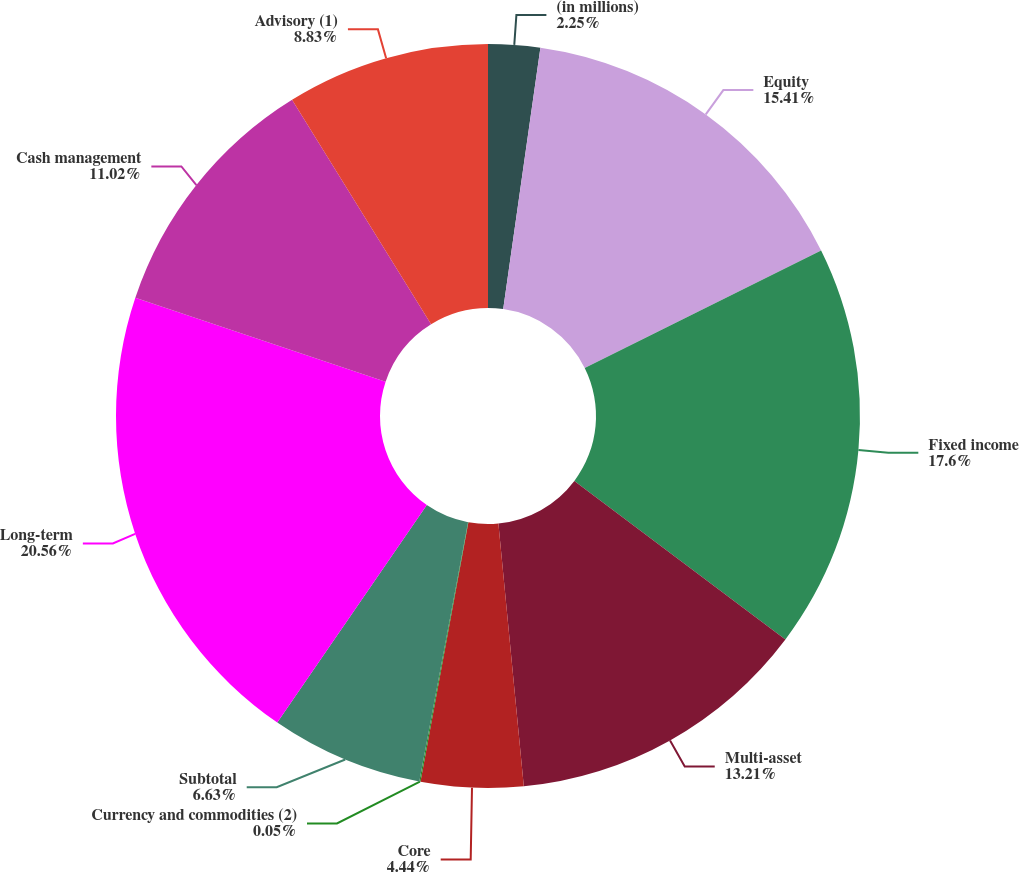Convert chart to OTSL. <chart><loc_0><loc_0><loc_500><loc_500><pie_chart><fcel>(in millions)<fcel>Equity<fcel>Fixed income<fcel>Multi-asset<fcel>Core<fcel>Currency and commodities (2)<fcel>Subtotal<fcel>Long-term<fcel>Cash management<fcel>Advisory (1)<nl><fcel>2.25%<fcel>15.41%<fcel>17.6%<fcel>13.21%<fcel>4.44%<fcel>0.05%<fcel>6.63%<fcel>20.57%<fcel>11.02%<fcel>8.83%<nl></chart> 